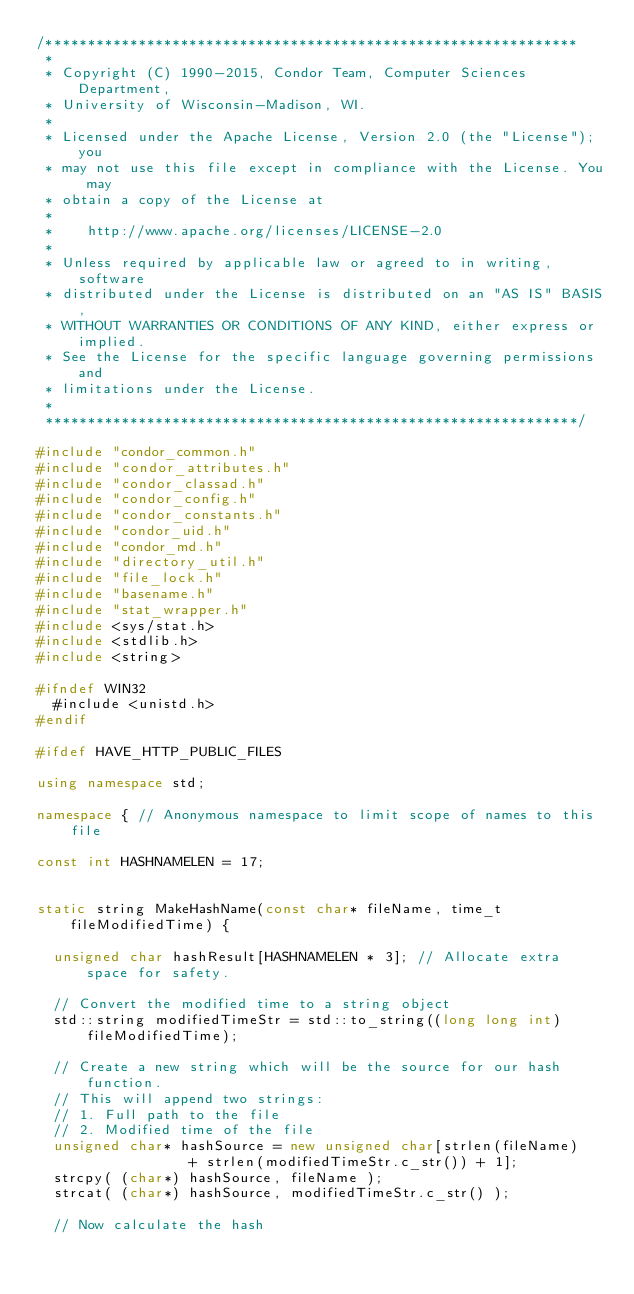Convert code to text. <code><loc_0><loc_0><loc_500><loc_500><_C++_>/***************************************************************
 *
 * Copyright (C) 1990-2015, Condor Team, Computer Sciences Department,
 * University of Wisconsin-Madison, WI.
 * 
 * Licensed under the Apache License, Version 2.0 (the "License"); you
 * may not use this file except in compliance with the License.	You may
 * obtain a copy of the License at
 * 
 *		http://www.apache.org/licenses/LICENSE-2.0
 * 
 * Unless required by applicable law or agreed to in writing, software
 * distributed under the License is distributed on an "AS IS" BASIS,
 * WITHOUT WARRANTIES OR CONDITIONS OF ANY KIND, either express or implied.
 * See the License for the specific language governing permissions and
 * limitations under the License.
 *
 ***************************************************************/

#include "condor_common.h"
#include "condor_attributes.h"
#include "condor_classad.h"
#include "condor_config.h"
#include "condor_constants.h"
#include "condor_uid.h"
#include "condor_md.h"
#include "directory_util.h"
#include "file_lock.h"
#include "basename.h"
#include "stat_wrapper.h"
#include <sys/stat.h>
#include <stdlib.h>
#include <string> 

#ifndef WIN32
	#include <unistd.h>
#endif

#ifdef HAVE_HTTP_PUBLIC_FILES

using namespace std;

namespace {	// Anonymous namespace to limit scope of names to this file
	
const int HASHNAMELEN = 17;


static string MakeHashName(const char* fileName, time_t fileModifiedTime) {

	unsigned char hashResult[HASHNAMELEN * 3]; // Allocate extra space for safety.

	// Convert the modified time to a string object
	std::string modifiedTimeStr = std::to_string((long long int) fileModifiedTime);

	// Create a new string which will be the source for our hash function.
	// This will append two strings:
	// 1. Full path to the file
	// 2. Modified time of the file
	unsigned char* hashSource = new unsigned char[strlen(fileName) 
									+ strlen(modifiedTimeStr.c_str()) + 1];
	strcpy( (char*) hashSource, fileName );
	strcat( (char*) hashSource, modifiedTimeStr.c_str() );

	// Now calculate the hash</code> 